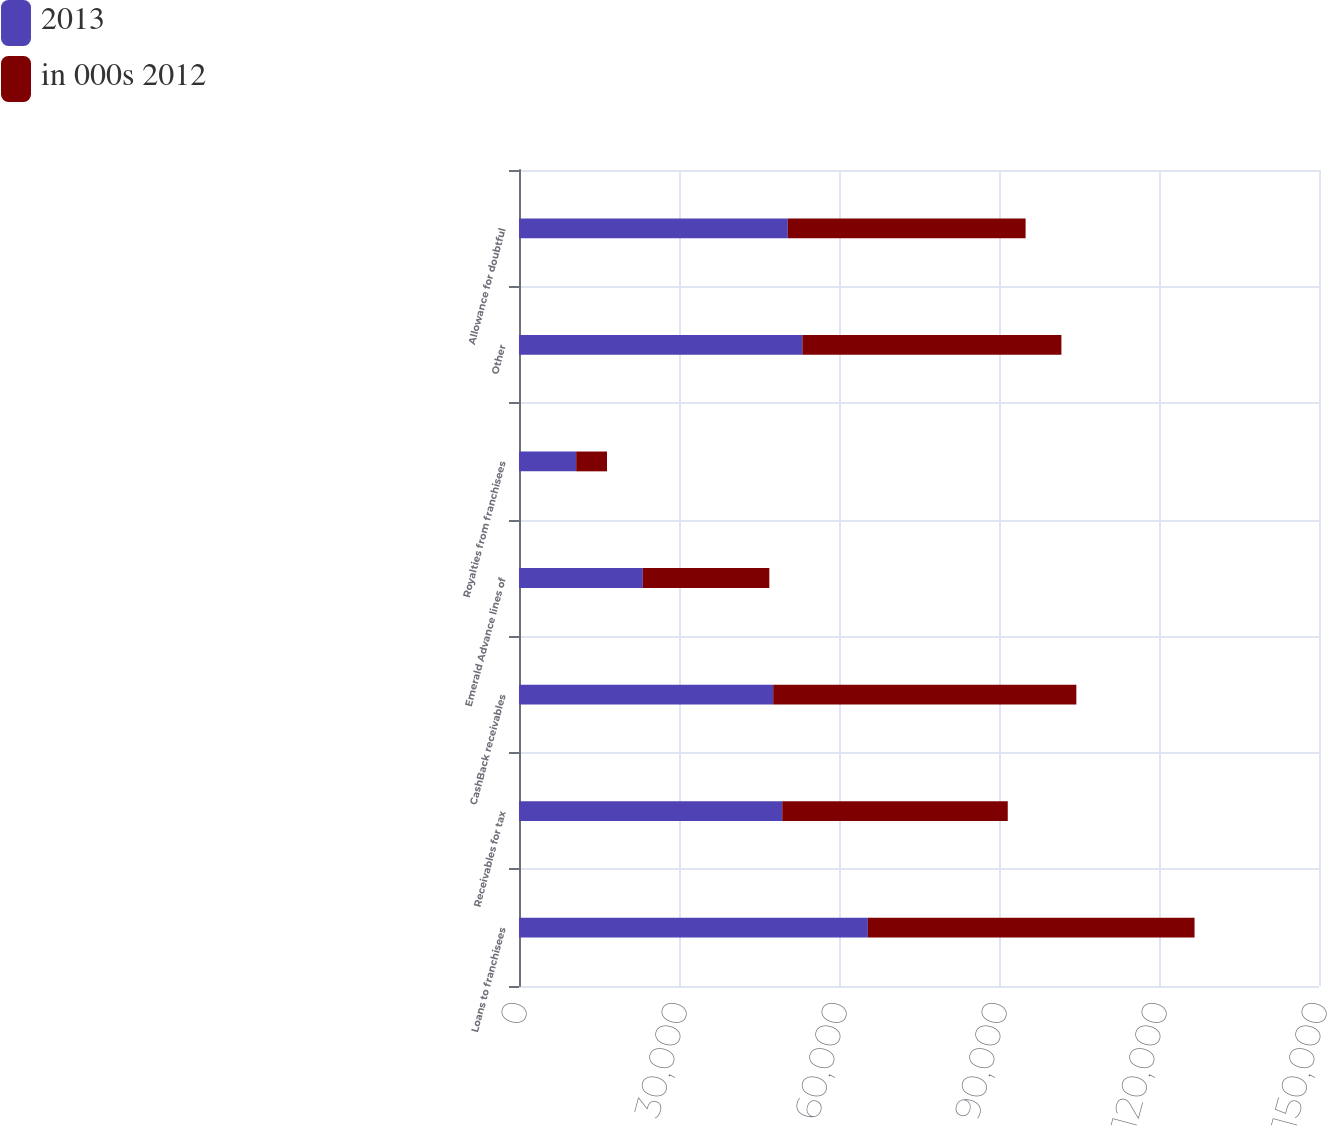Convert chart to OTSL. <chart><loc_0><loc_0><loc_500><loc_500><stacked_bar_chart><ecel><fcel>Loans to franchisees<fcel>Receivables for tax<fcel>CashBack receivables<fcel>Emerald Advance lines of<fcel>Royalties from franchisees<fcel>Other<fcel>Allowance for doubtful<nl><fcel>2013<fcel>65413<fcel>49356<fcel>47658<fcel>23218<fcel>10722<fcel>53134<fcel>50399<nl><fcel>in 000s 2012<fcel>61252<fcel>42286<fcel>56846<fcel>23717<fcel>5781<fcel>48565<fcel>44589<nl></chart> 